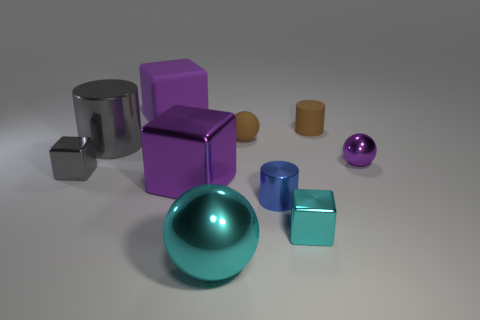There is a ball that is the same size as the purple rubber block; what color is it?
Ensure brevity in your answer.  Cyan. What number of other objects are there of the same shape as the large gray shiny thing?
Make the answer very short. 2. Does the blue cylinder have the same size as the cylinder that is on the left side of the tiny blue cylinder?
Ensure brevity in your answer.  No. What number of things are either tiny gray metal objects or tiny blocks?
Make the answer very short. 2. What number of other objects are there of the same size as the matte cylinder?
Ensure brevity in your answer.  5. There is a matte block; is it the same color as the big cube that is in front of the small matte ball?
Offer a very short reply. Yes. What number of cylinders are small blue things or big metal things?
Ensure brevity in your answer.  2. Are there any other things of the same color as the small metallic cylinder?
Your answer should be compact. No. What material is the sphere in front of the gray shiny thing that is to the left of the gray cylinder made of?
Your answer should be compact. Metal. Is the material of the large gray cylinder the same as the large purple object that is behind the large gray cylinder?
Keep it short and to the point. No. 